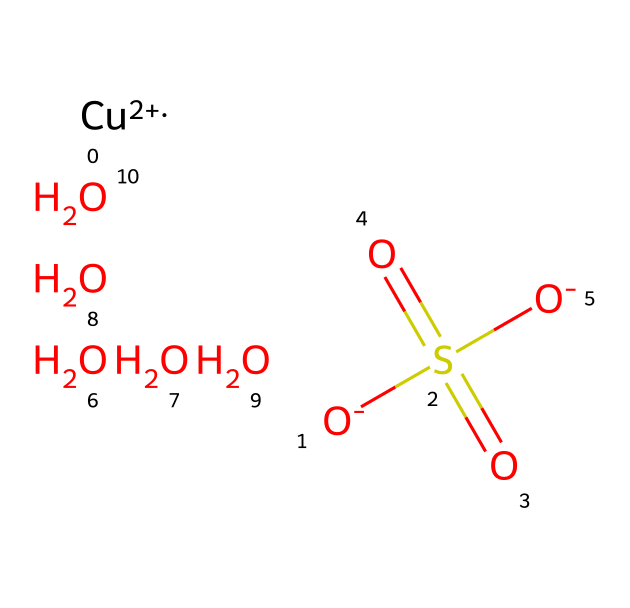What is the chemical name of the compound represented by the SMILES? The SMILES represents copper(II) sulfate, as indicated by the presence of the copper cation [Cu+2] combined with the sulfate anion S(=O)(=O)[O-].
Answer: copper(II) sulfate How many oxygen atoms are present in the molecule? From the SMILES representation, we can see the sulfate group (S(=O)(=O)[O-]) contributes 4 oxygen atoms, and there are 2 additional oxygen atoms (the lone O's in the SMILES), totaling 6.
Answer: 6 What is the oxidation state of copper in this compound? The [Cu+2] part of the SMILES indicates that copper has a +2 oxidation state in this compound.
Answer: +2 What role does the sulfate group play in copper sulfate? The sulfate group acts as the anion that stabilizes the copper cation, forming the characteristic structure of copper sulfate.
Answer: anion How many total atoms are present in the molecule? Counting the atoms from the SMILES, we have 1 copper, 1 sulfur, and 6 oxygen, which adds up to 8 total atoms.
Answer: 8 What type of bonding is predominantly seen in copper sulfate? The SMILES shows a coordination complex where the copper ion is coordinated with the sulfate anion, indicating ionic bonding.
Answer: ionic bonding 